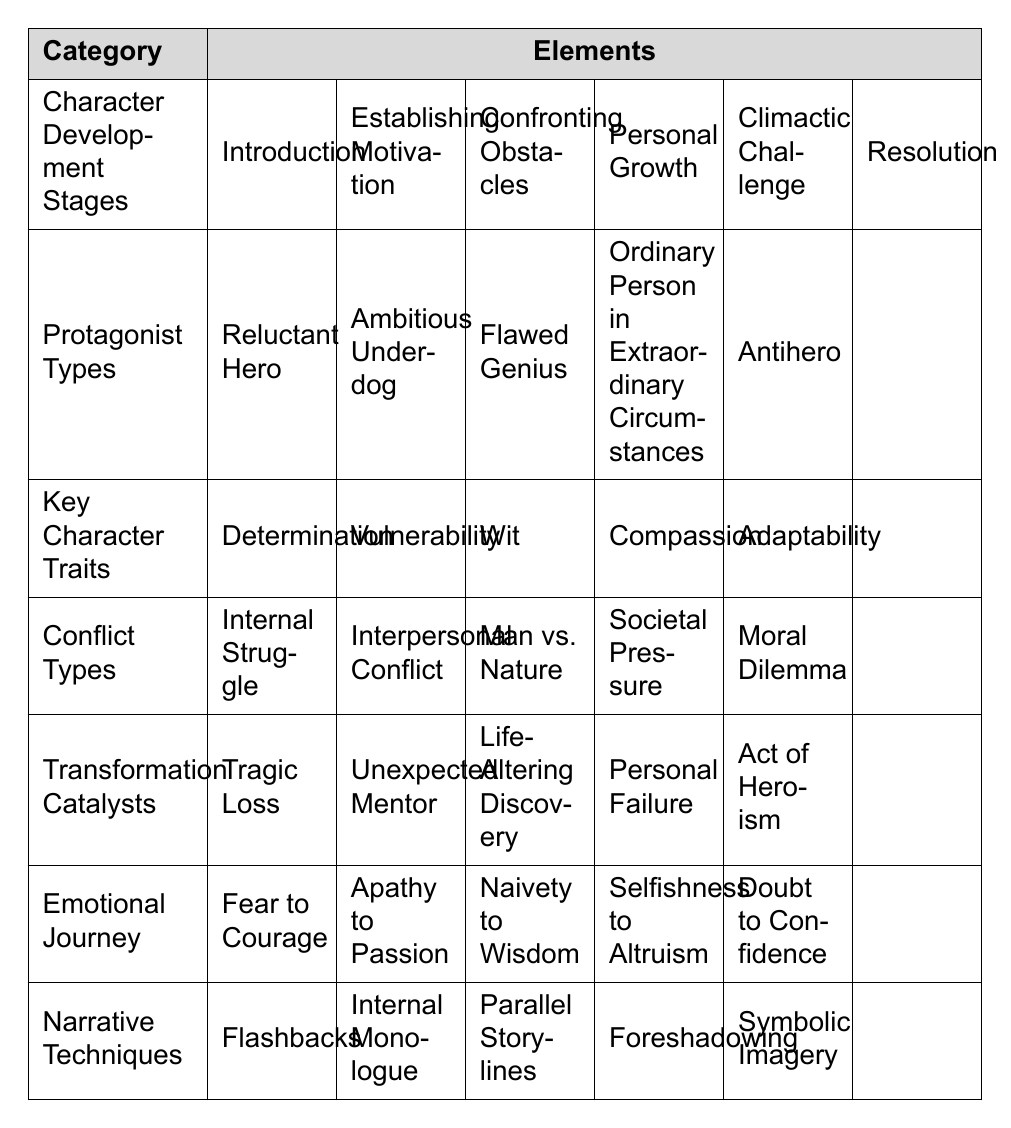What are the main Character Development Stages? The table lists six stages: Introduction, Establishing Motivation, Confronting Obstacles, Personal Growth, Climactic Challenge, and Resolution.
Answer: Introduction, Establishing Motivation, Confronting Obstacles, Personal Growth, Climactic Challenge, Resolution Which Protagonist Type is characterized by a personal journey toward self-discovery? The 'Flawed Genius' often undergoes self-discovery through their flaws, alongside high intellect.
Answer: Flawed Genius What are the Key Character Traits associated with overcoming conflict? The table lists five traits: Determination, Vulnerability, Wit, Compassion, and Adaptability. These traits help protagonists in their development and conflict resolution.
Answer: Determination, Vulnerability, Wit, Compassion, Adaptability Which type of conflict is characterized as a battle within oneself? 'Internal Struggle' describes the conflict taking place within a character's mind or emotions.
Answer: Internal Struggle What are the Transformation Catalysts that can lead to significant character changes? The table shows five catalysts: Tragic Loss, Unexpected Mentor, Life-Altering Discovery, Personal Failure, and Act of Heroism.
Answer: Tragic Loss, Unexpected Mentor, Life-Altering Discovery, Personal Failure, Act of Heroism What emotional journey do protagonists typically undergo from doubt? Protagonists often experience a shift from Doubt to Confidence on their emotional journey.
Answer: Doubt to Confidence Which Narrative Technique involves revealing past events to enhance the story? 'Flashbacks' are used as a narrative technique to provide background and depth to the character's development.
Answer: Flashbacks How many types of Protagonist Types are listed in the table? The table lists five types of protagonists: Reluctant Hero, Ambitious Underdog, Flawed Genius, Ordinary Person in Extraordinary Circumstances, and Antihero.
Answer: Five What would be a likely emotional journey for an 'Ordinary Person in Extraordinary Circumstances'? This type of protagonist may journey from Apathy to Passion, developing as they face unusual events.
Answer: Apathy to Passion Which Key Character Trait is considered vital for overcoming societal challenges? 'Adaptability' is crucial for protagonists facing societal pressures as it helps them adjust and find solutions.
Answer: Adaptability What would you find as a Transformation Catalyst for a character who has failed? 'Personal Failure' can serve as a catalyst for transformation, helping the character change and grow.
Answer: Personal Failure Can you list the Narrative Techniques that aid in character development? The techniques include Flashbacks, Internal Monologue, Parallel Storylines, Foreshadowing, and Symbolic Imagery, all contributing to depth.
Answer: Flashbacks, Internal Monologue, Parallel Storylines, Foreshadowing, Symbolic Imagery Which protagonist type could represent a heroic yet morally ambiguous figure? The 'Antihero' typically embodies moral ambiguity, acting heroically but employing questionable methods.
Answer: Antihero What is the relationship between confrontation of obstacles and personal growth? Confronting obstacles often leads directly to Personal Growth in the character's development arc, as they learn from experiences.
Answer: They are directly related 